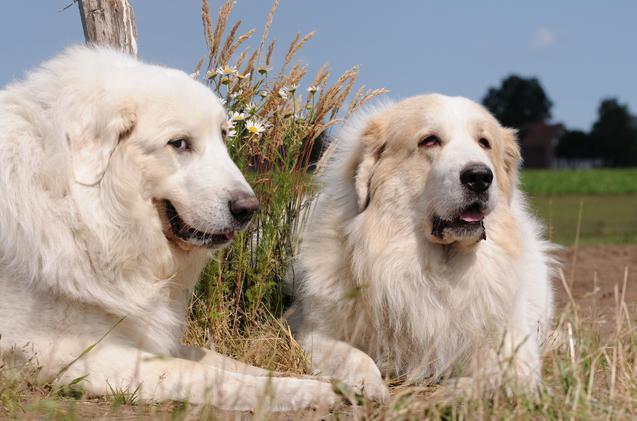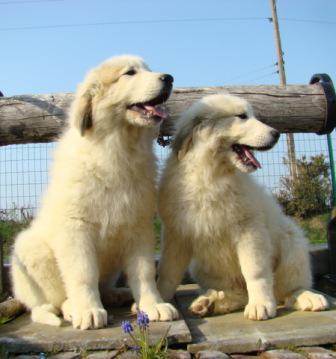The first image is the image on the left, the second image is the image on the right. Analyze the images presented: Is the assertion "Left image shows two dogs posed together outdoors." valid? Answer yes or no. Yes. 